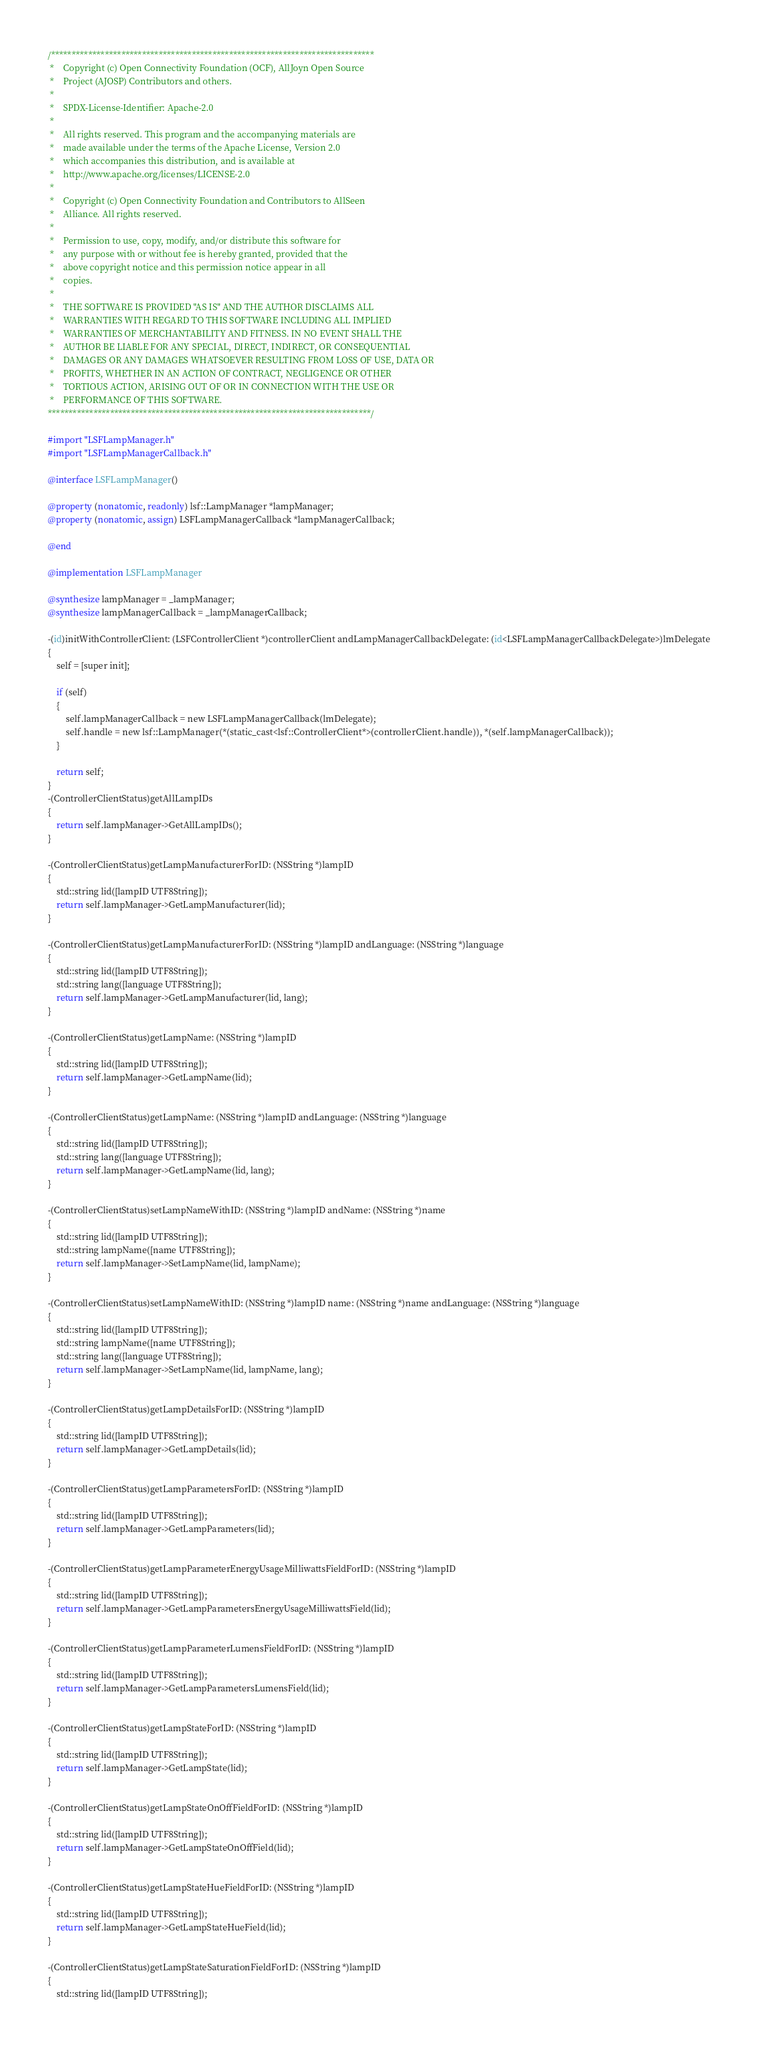Convert code to text. <code><loc_0><loc_0><loc_500><loc_500><_ObjectiveC_>/******************************************************************************
 *    Copyright (c) Open Connectivity Foundation (OCF), AllJoyn Open Source
 *    Project (AJOSP) Contributors and others.
 *    
 *    SPDX-License-Identifier: Apache-2.0
 *    
 *    All rights reserved. This program and the accompanying materials are
 *    made available under the terms of the Apache License, Version 2.0
 *    which accompanies this distribution, and is available at
 *    http://www.apache.org/licenses/LICENSE-2.0
 *    
 *    Copyright (c) Open Connectivity Foundation and Contributors to AllSeen
 *    Alliance. All rights reserved.
 *    
 *    Permission to use, copy, modify, and/or distribute this software for
 *    any purpose with or without fee is hereby granted, provided that the
 *    above copyright notice and this permission notice appear in all
 *    copies.
 *    
 *    THE SOFTWARE IS PROVIDED "AS IS" AND THE AUTHOR DISCLAIMS ALL
 *    WARRANTIES WITH REGARD TO THIS SOFTWARE INCLUDING ALL IMPLIED
 *    WARRANTIES OF MERCHANTABILITY AND FITNESS. IN NO EVENT SHALL THE
 *    AUTHOR BE LIABLE FOR ANY SPECIAL, DIRECT, INDIRECT, OR CONSEQUENTIAL
 *    DAMAGES OR ANY DAMAGES WHATSOEVER RESULTING FROM LOSS OF USE, DATA OR
 *    PROFITS, WHETHER IN AN ACTION OF CONTRACT, NEGLIGENCE OR OTHER
 *    TORTIOUS ACTION, ARISING OUT OF OR IN CONNECTION WITH THE USE OR
 *    PERFORMANCE OF THIS SOFTWARE.
******************************************************************************/

#import "LSFLampManager.h"
#import "LSFLampManagerCallback.h"

@interface LSFLampManager()

@property (nonatomic, readonly) lsf::LampManager *lampManager;
@property (nonatomic, assign) LSFLampManagerCallback *lampManagerCallback;

@end

@implementation LSFLampManager

@synthesize lampManager = _lampManager;
@synthesize lampManagerCallback = _lampManagerCallback;

-(id)initWithControllerClient: (LSFControllerClient *)controllerClient andLampManagerCallbackDelegate: (id<LSFLampManagerCallbackDelegate>)lmDelegate
{
    self = [super init];
    
    if (self)
    {
        self.lampManagerCallback = new LSFLampManagerCallback(lmDelegate);
        self.handle = new lsf::LampManager(*(static_cast<lsf::ControllerClient*>(controllerClient.handle)), *(self.lampManagerCallback));
    }
    
    return self;
}
-(ControllerClientStatus)getAllLampIDs
{
    return self.lampManager->GetAllLampIDs();
}

-(ControllerClientStatus)getLampManufacturerForID: (NSString *)lampID
{
    std::string lid([lampID UTF8String]);
    return self.lampManager->GetLampManufacturer(lid);
}

-(ControllerClientStatus)getLampManufacturerForID: (NSString *)lampID andLanguage: (NSString *)language
{
    std::string lid([lampID UTF8String]);
    std::string lang([language UTF8String]);
    return self.lampManager->GetLampManufacturer(lid, lang);
}

-(ControllerClientStatus)getLampName: (NSString *)lampID
{
    std::string lid([lampID UTF8String]);
    return self.lampManager->GetLampName(lid);
}

-(ControllerClientStatus)getLampName: (NSString *)lampID andLanguage: (NSString *)language
{
    std::string lid([lampID UTF8String]);
    std::string lang([language UTF8String]);
    return self.lampManager->GetLampName(lid, lang);
}

-(ControllerClientStatus)setLampNameWithID: (NSString *)lampID andName: (NSString *)name
{
    std::string lid([lampID UTF8String]);
    std::string lampName([name UTF8String]);
    return self.lampManager->SetLampName(lid, lampName);
}

-(ControllerClientStatus)setLampNameWithID: (NSString *)lampID name: (NSString *)name andLanguage: (NSString *)language
{
    std::string lid([lampID UTF8String]);
    std::string lampName([name UTF8String]);
    std::string lang([language UTF8String]);
    return self.lampManager->SetLampName(lid, lampName, lang);
}

-(ControllerClientStatus)getLampDetailsForID: (NSString *)lampID
{
    std::string lid([lampID UTF8String]);
    return self.lampManager->GetLampDetails(lid);
}

-(ControllerClientStatus)getLampParametersForID: (NSString *)lampID
{
    std::string lid([lampID UTF8String]);
    return self.lampManager->GetLampParameters(lid);
}

-(ControllerClientStatus)getLampParameterEnergyUsageMilliwattsFieldForID: (NSString *)lampID
{
    std::string lid([lampID UTF8String]);
    return self.lampManager->GetLampParametersEnergyUsageMilliwattsField(lid);
}

-(ControllerClientStatus)getLampParameterLumensFieldForID: (NSString *)lampID
{
    std::string lid([lampID UTF8String]);
    return self.lampManager->GetLampParametersLumensField(lid);
}

-(ControllerClientStatus)getLampStateForID: (NSString *)lampID
{
    std::string lid([lampID UTF8String]);
    return self.lampManager->GetLampState(lid);
}

-(ControllerClientStatus)getLampStateOnOffFieldForID: (NSString *)lampID
{
    std::string lid([lampID UTF8String]);
    return self.lampManager->GetLampStateOnOffField(lid);
}

-(ControllerClientStatus)getLampStateHueFieldForID: (NSString *)lampID
{
    std::string lid([lampID UTF8String]);
    return self.lampManager->GetLampStateHueField(lid);
}

-(ControllerClientStatus)getLampStateSaturationFieldForID: (NSString *)lampID
{
    std::string lid([lampID UTF8String]);</code> 